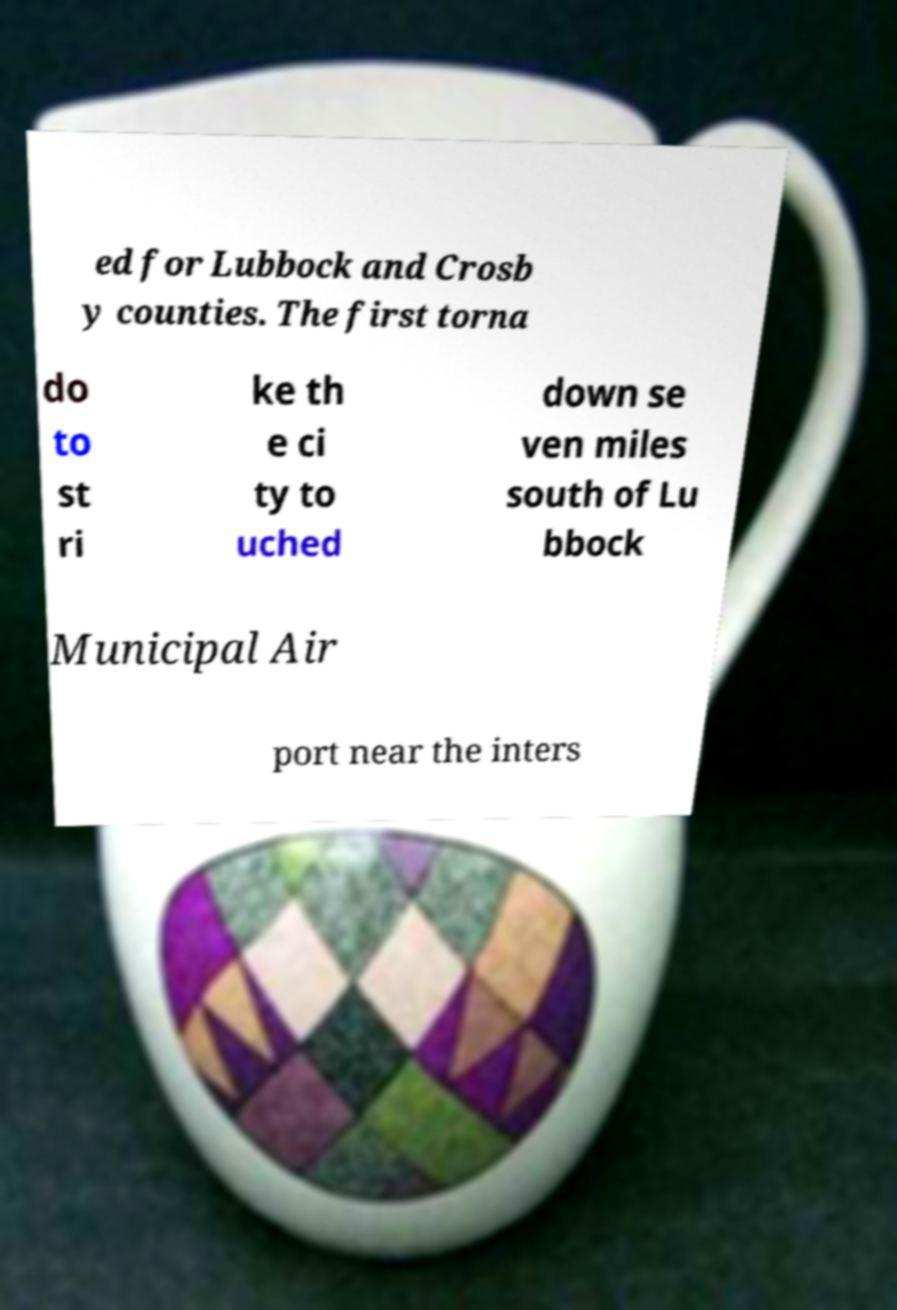For documentation purposes, I need the text within this image transcribed. Could you provide that? ed for Lubbock and Crosb y counties. The first torna do to st ri ke th e ci ty to uched down se ven miles south of Lu bbock Municipal Air port near the inters 